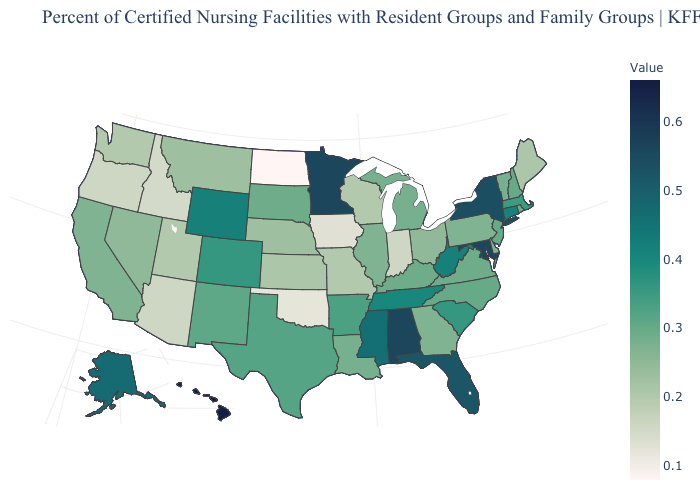Among the states that border Colorado , which have the highest value?
Quick response, please. Wyoming. Does New Mexico have the highest value in the USA?
Keep it brief. No. Among the states that border Texas , does Oklahoma have the highest value?
Quick response, please. No. Which states hav the highest value in the Northeast?
Be succinct. New York. Does Vermont have the highest value in the Northeast?
Answer briefly. No. 